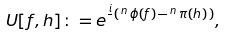<formula> <loc_0><loc_0><loc_500><loc_500>U [ f , h ] \colon = e ^ { \frac { i } { } ( \, ^ { n } \, \phi ( f ) \, - \, ^ { n } \, \pi ( h ) \, ) } ,</formula> 